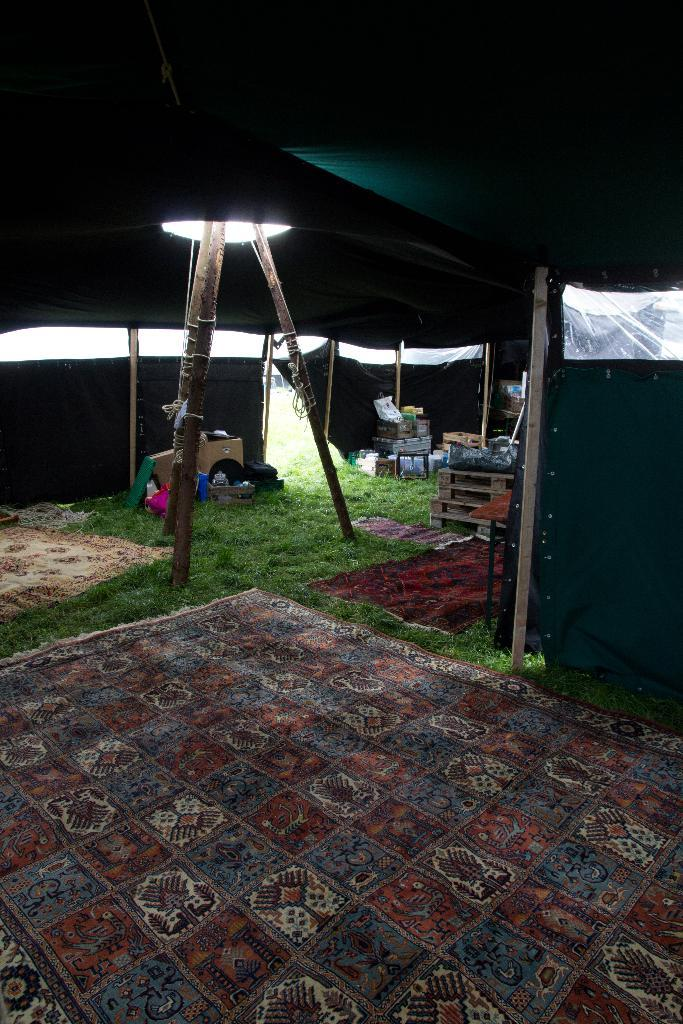What structures can be seen in the image? There are poles in the image. What type of shelter is present in the image? There is a tent in the image. What can be seen hanging or placed on the poles or tent? Clothes are visible in the image. What type of storage containers are present in the image? There are carton boxes in the image. What else can be seen in the image besides the mentioned items? There are various objects and things in the image. What type of ground surface is visible in the image? Grass is present in the image. What type of flooring or seating is visible in the image? Mats are visible in the image. What type of engine can be seen powering the tent in the image? There is no engine present in the image, and the tent is not powered by any engine. What part of the body is visible in the image, specifically the elbow? There is no part of the body, including an elbow, visible in the image. 